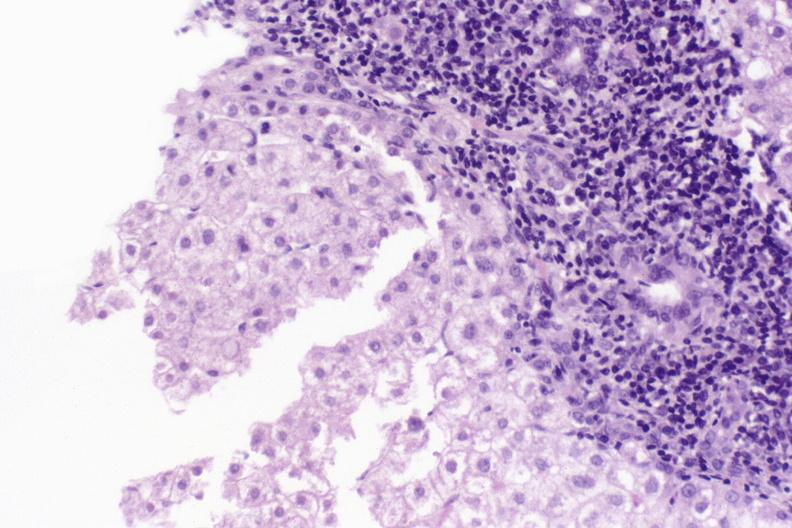s fetus developing very early present?
Answer the question using a single word or phrase. No 